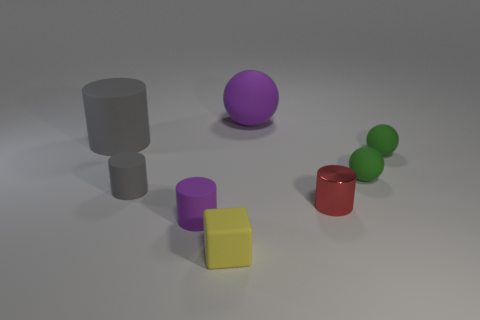What is the material of the small cylinder in front of the red metal cylinder?
Give a very brief answer. Rubber. Are there fewer large purple matte objects in front of the tiny gray object than tiny red objects?
Make the answer very short. Yes. There is a big rubber thing that is in front of the purple rubber object that is behind the small metallic cylinder; what is its shape?
Offer a terse response. Cylinder. What color is the tiny cube?
Make the answer very short. Yellow. What number of other objects are the same size as the yellow matte object?
Make the answer very short. 5. There is a thing that is both to the right of the tiny purple rubber thing and in front of the tiny red metallic cylinder; what material is it?
Make the answer very short. Rubber. There is a purple thing that is behind the red metallic cylinder; is its size the same as the large gray cylinder?
Ensure brevity in your answer.  Yes. Is the color of the tiny rubber block the same as the large ball?
Provide a succinct answer. No. What number of objects are in front of the large cylinder and left of the red metallic object?
Provide a short and direct response. 3. There is a ball behind the large object on the left side of the small purple rubber cylinder; what number of tiny cylinders are left of it?
Make the answer very short. 2. 